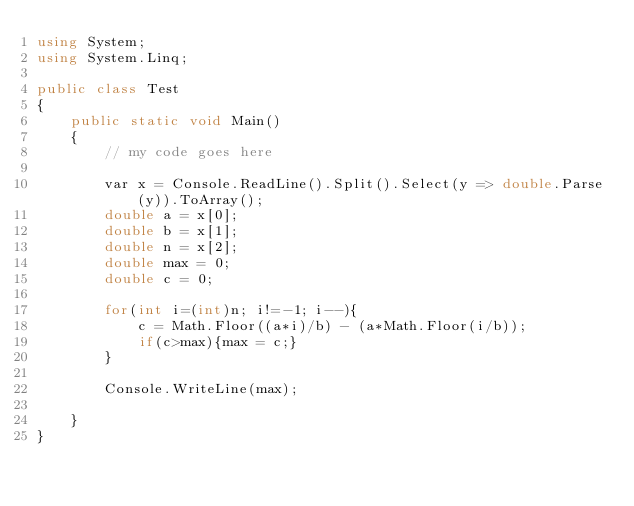<code> <loc_0><loc_0><loc_500><loc_500><_C#_>using System;
using System.Linq;

public class Test
{
	public static void Main()
	{
		// my code goes here
		
		var x = Console.ReadLine().Split().Select(y => double.Parse(y)).ToArray();
		double a = x[0];
		double b = x[1];
		double n = x[2];
		double max = 0;
		double c = 0;
		
		for(int i=(int)n; i!=-1; i--){
			c = Math.Floor((a*i)/b) - (a*Math.Floor(i/b));
			if(c>max){max = c;}
		}
		
		Console.WriteLine(max);
		
	}
}</code> 